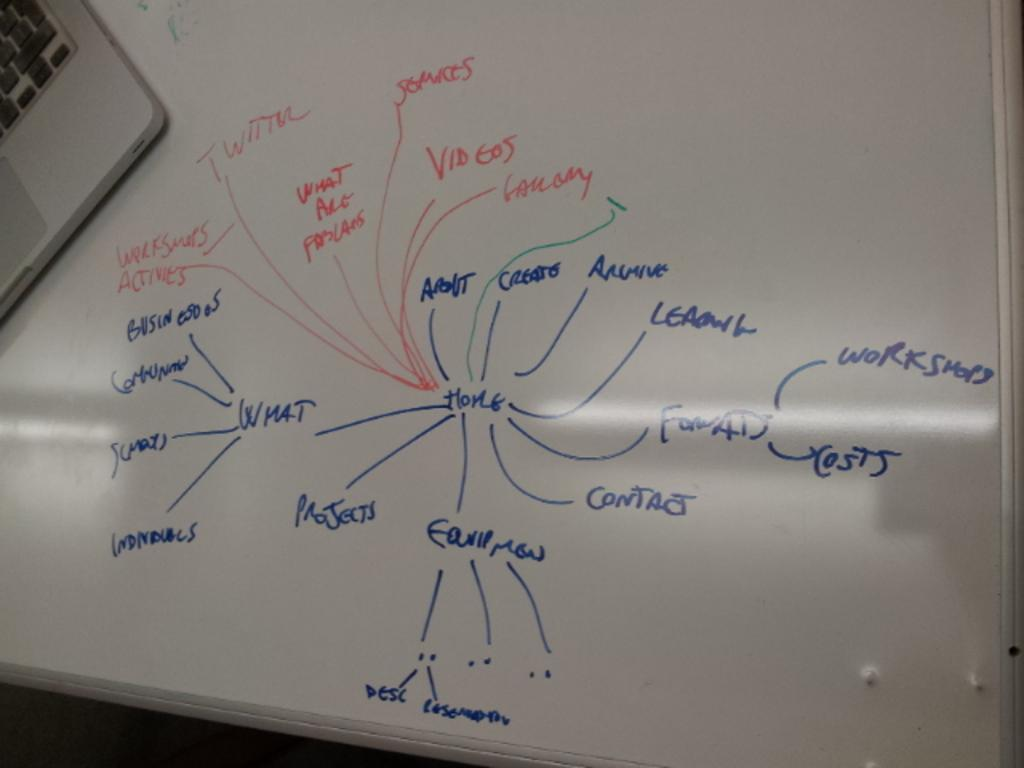Provide a one-sentence caption for the provided image. A whiteboard contains diagrams containing terms such as projects, contact, costs and workshops. 